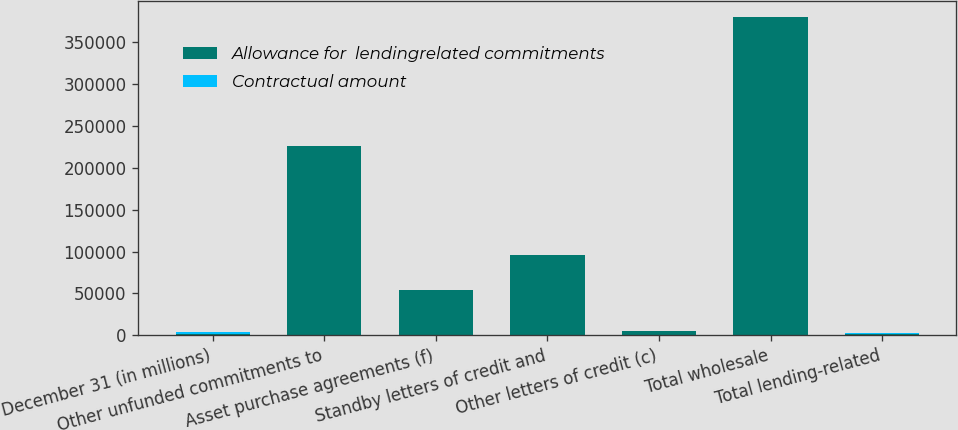Convert chart. <chart><loc_0><loc_0><loc_500><loc_500><stacked_bar_chart><ecel><fcel>December 31 (in millions)<fcel>Other unfunded commitments to<fcel>Asset purchase agreements (f)<fcel>Standby letters of credit and<fcel>Other letters of credit (c)<fcel>Total wholesale<fcel>Total lending-related<nl><fcel>Allowance for  lendingrelated commitments<fcel>2008<fcel>225863<fcel>53729<fcel>95352<fcel>4927<fcel>379871<fcel>2008<nl><fcel>Contractual amount<fcel>2008<fcel>349<fcel>9<fcel>274<fcel>2<fcel>634<fcel>659<nl></chart> 